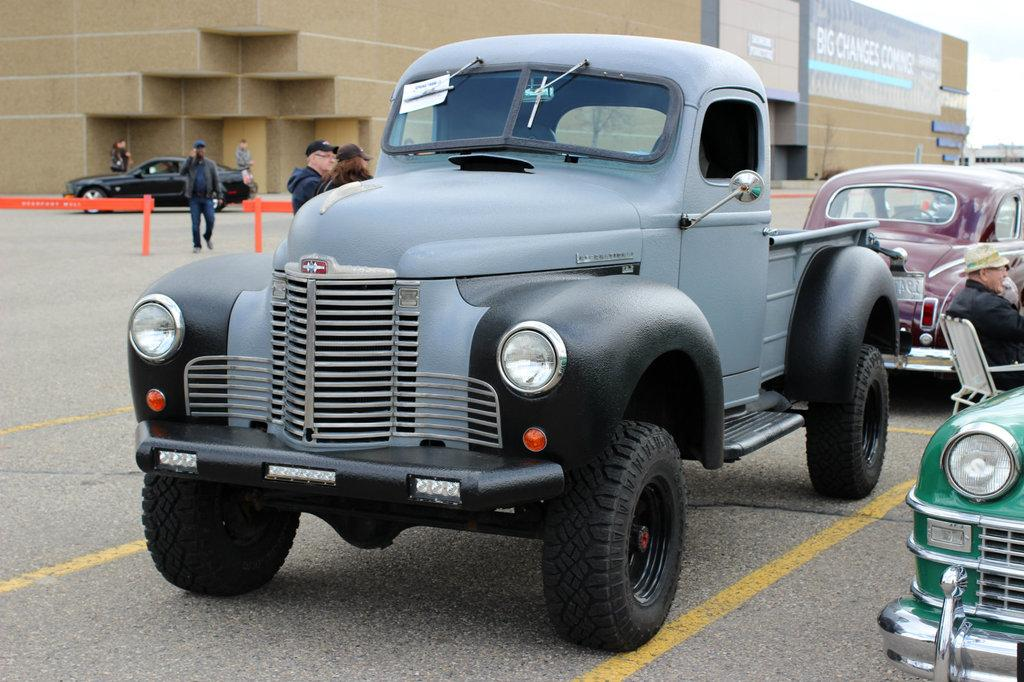What types of objects are on the ground in the image? There are vehicles on the ground in the image. What else can be seen in the image besides the vehicles? There is a group of people, a fence, buildings, boards with text, and the sky is visible in the image. Can you describe the group of people in the image? The group of people in the image consists of multiple individuals. What is the purpose of the boards with text in the image? The purpose of the boards with text in the image is not clear from the provided facts, but they likely contain some form of information or message. How many toes are visible on the vehicles in the image? Vehicles do not have toes, as they are inanimate objects. The question is not applicable to the image. 